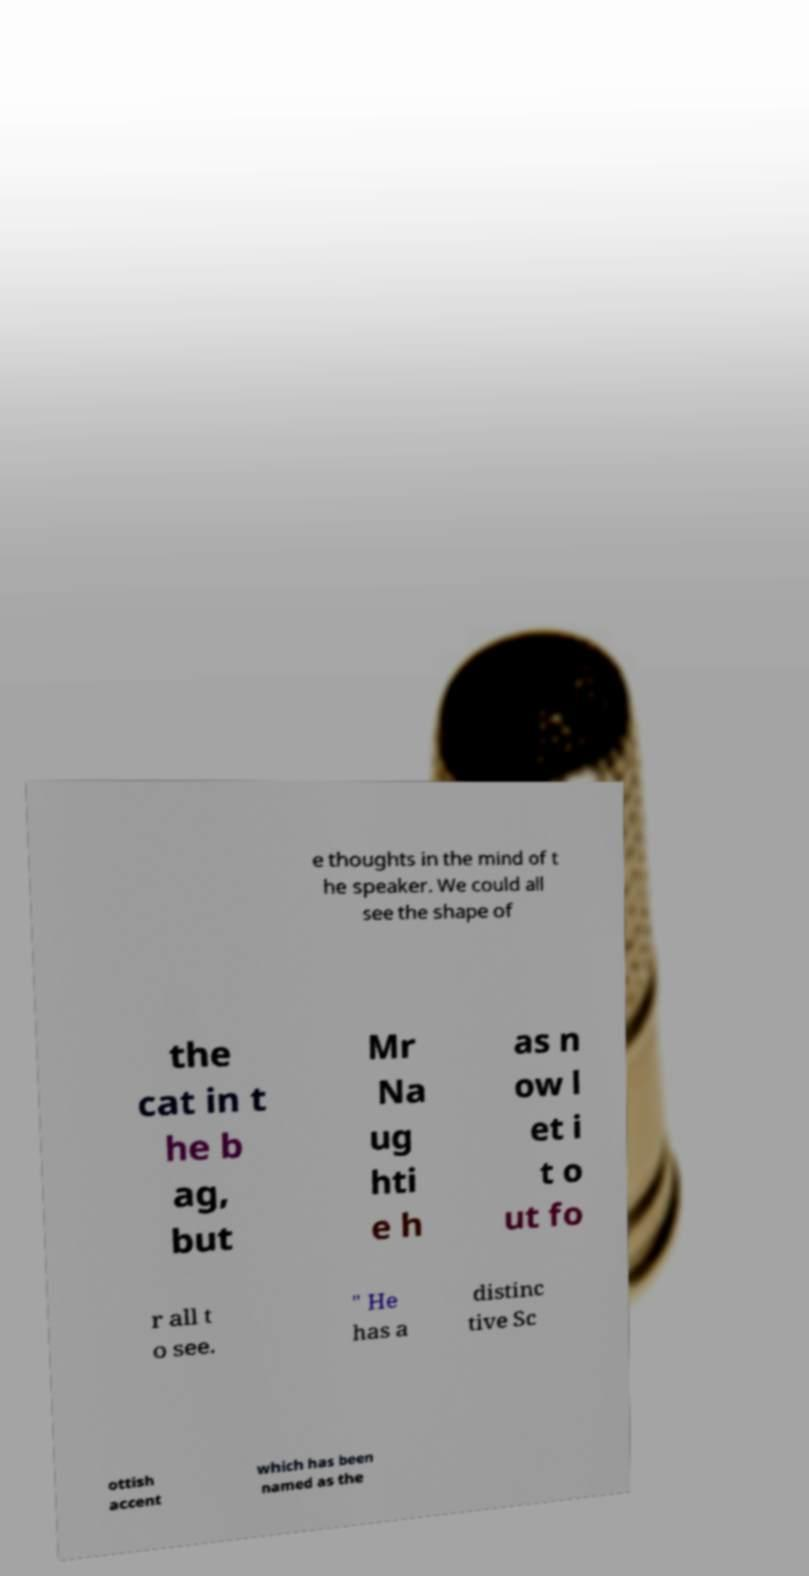Please identify and transcribe the text found in this image. e thoughts in the mind of t he speaker. We could all see the shape of the cat in t he b ag, but Mr Na ug hti e h as n ow l et i t o ut fo r all t o see. " He has a distinc tive Sc ottish accent which has been named as the 